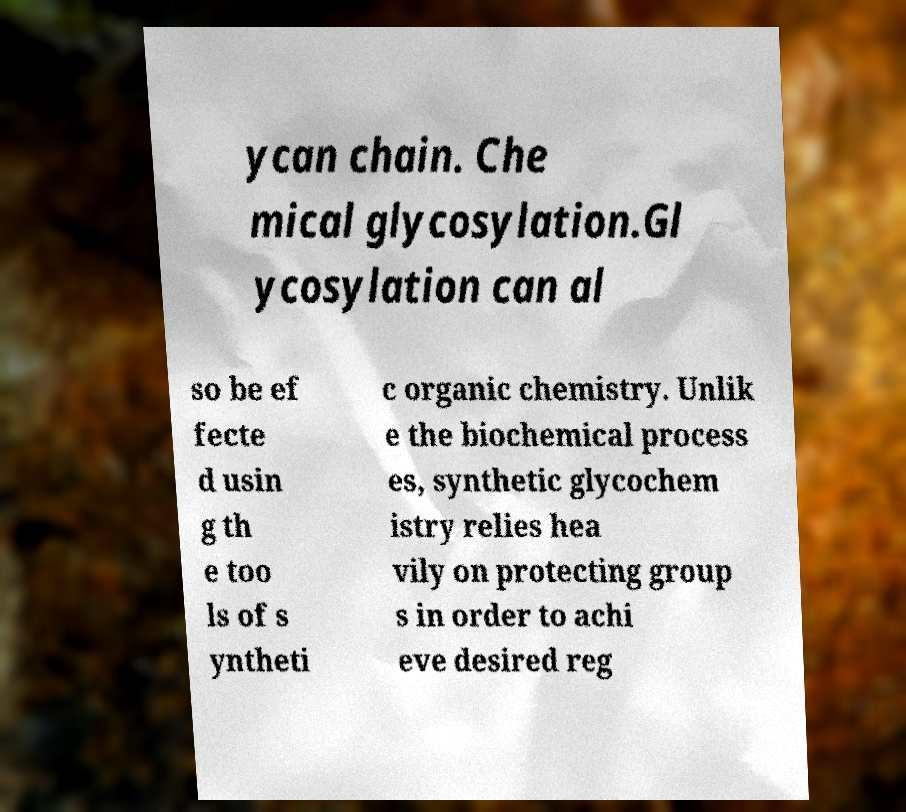I need the written content from this picture converted into text. Can you do that? ycan chain. Che mical glycosylation.Gl ycosylation can al so be ef fecte d usin g th e too ls of s yntheti c organic chemistry. Unlik e the biochemical process es, synthetic glycochem istry relies hea vily on protecting group s in order to achi eve desired reg 